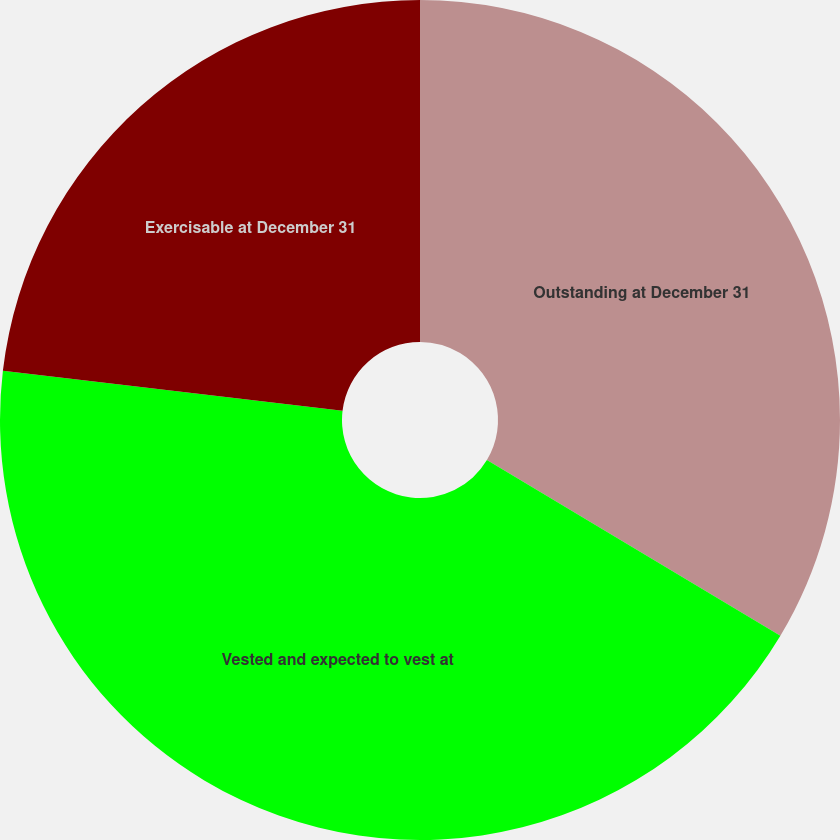<chart> <loc_0><loc_0><loc_500><loc_500><pie_chart><fcel>Outstanding at December 31<fcel>Vested and expected to vest at<fcel>Exercisable at December 31<nl><fcel>33.58%<fcel>43.28%<fcel>23.13%<nl></chart> 